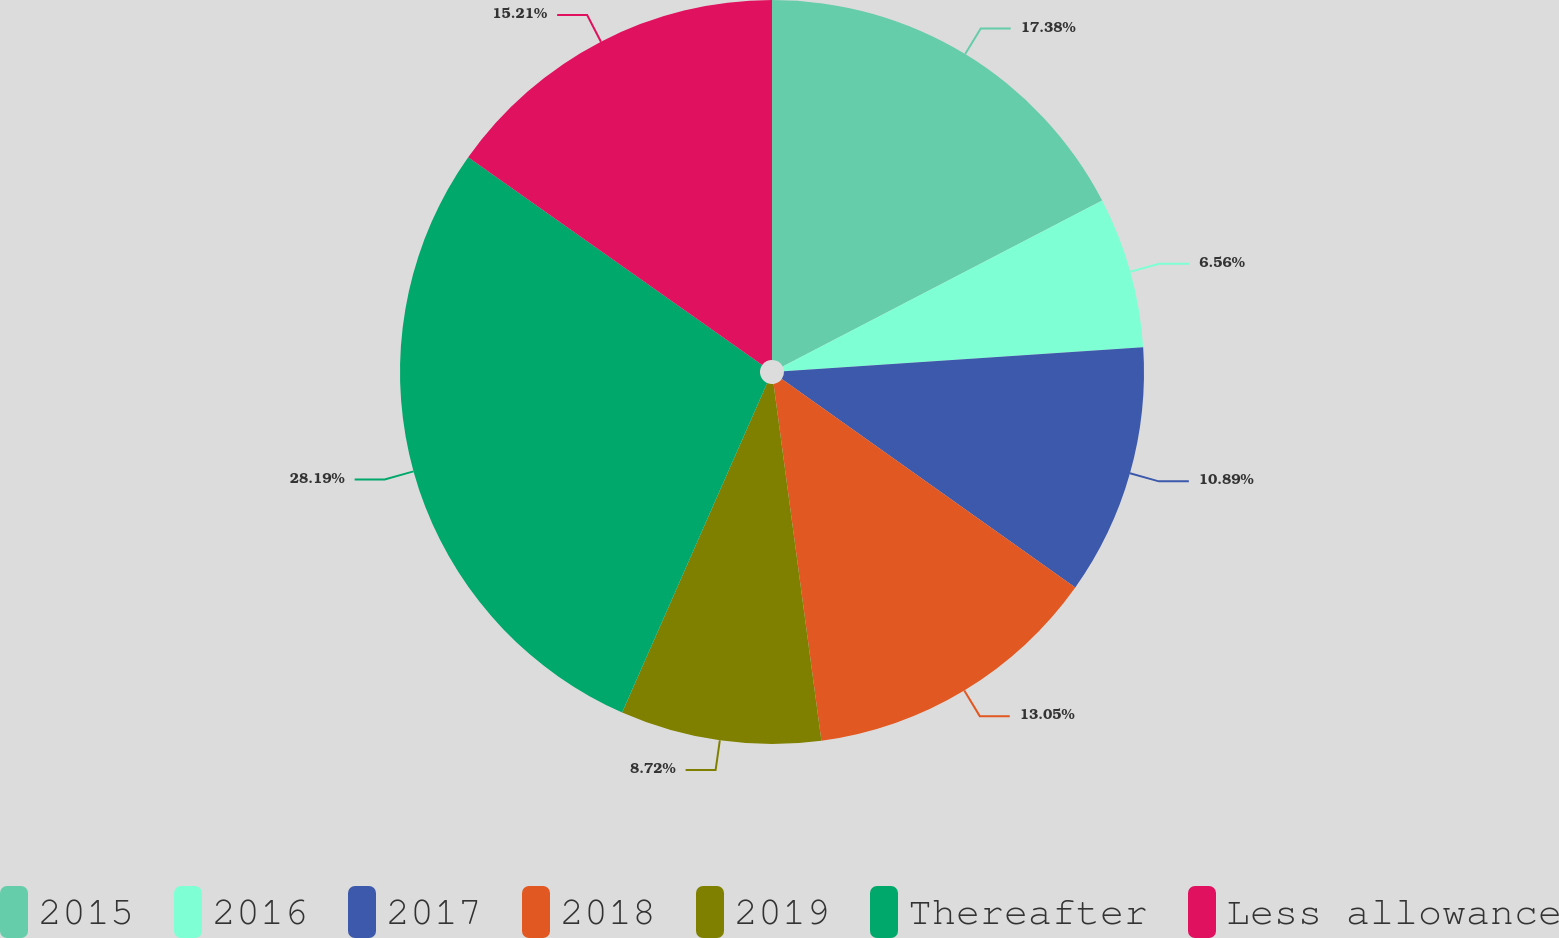Convert chart to OTSL. <chart><loc_0><loc_0><loc_500><loc_500><pie_chart><fcel>2015<fcel>2016<fcel>2017<fcel>2018<fcel>2019<fcel>Thereafter<fcel>Less allowance<nl><fcel>17.38%<fcel>6.56%<fcel>10.89%<fcel>13.05%<fcel>8.72%<fcel>28.19%<fcel>15.21%<nl></chart> 